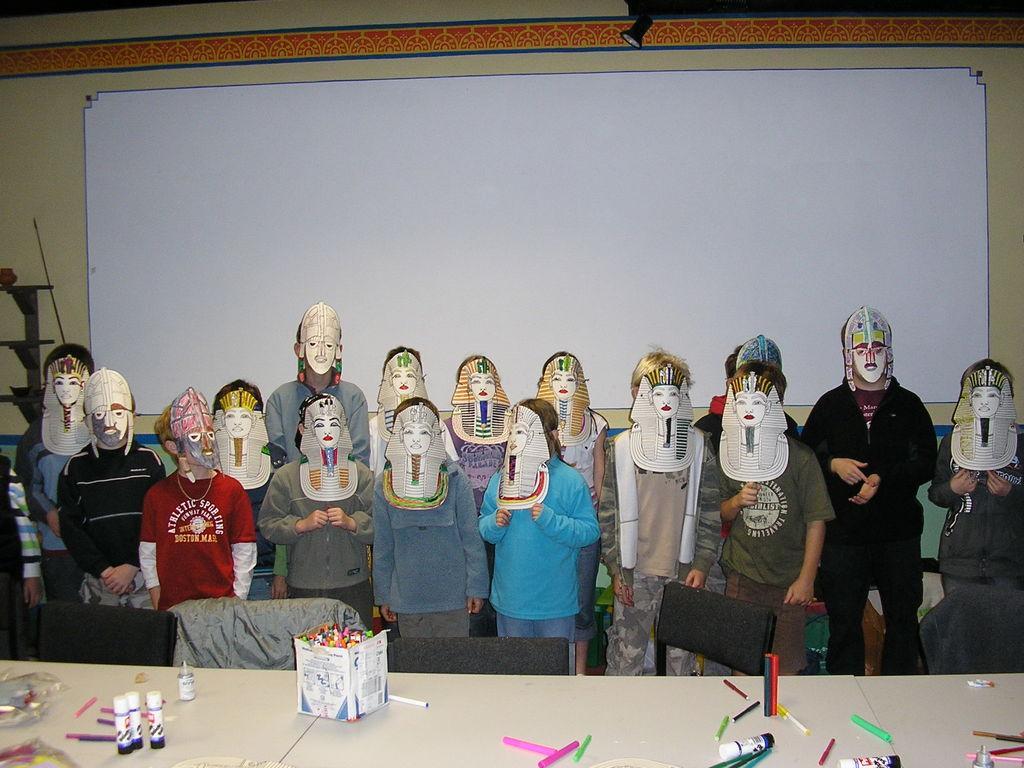Can you describe this image briefly? At the bottom of the image there is a table, on the table there are some pens and bottles. Behind the table there are some chairs. In the middle of the image few persons are standing. Behind them there is a wall, on the wall there is a board. 